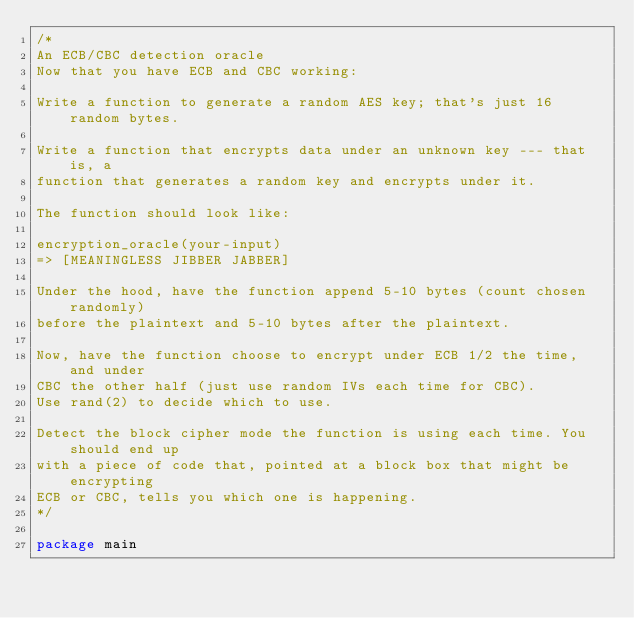Convert code to text. <code><loc_0><loc_0><loc_500><loc_500><_Go_>/*
An ECB/CBC detection oracle
Now that you have ECB and CBC working:

Write a function to generate a random AES key; that's just 16 random bytes.

Write a function that encrypts data under an unknown key --- that is, a
function that generates a random key and encrypts under it.

The function should look like:

encryption_oracle(your-input)
=> [MEANINGLESS JIBBER JABBER]

Under the hood, have the function append 5-10 bytes (count chosen randomly)
before the plaintext and 5-10 bytes after the plaintext.

Now, have the function choose to encrypt under ECB 1/2 the time, and under
CBC the other half (just use random IVs each time for CBC).
Use rand(2) to decide which to use.

Detect the block cipher mode the function is using each time. You should end up
with a piece of code that, pointed at a block box that might be encrypting
ECB or CBC, tells you which one is happening.
*/

package main</code> 